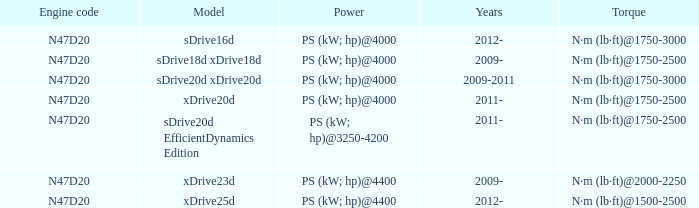What is the engine code of the xdrive23d model? N47D20. 